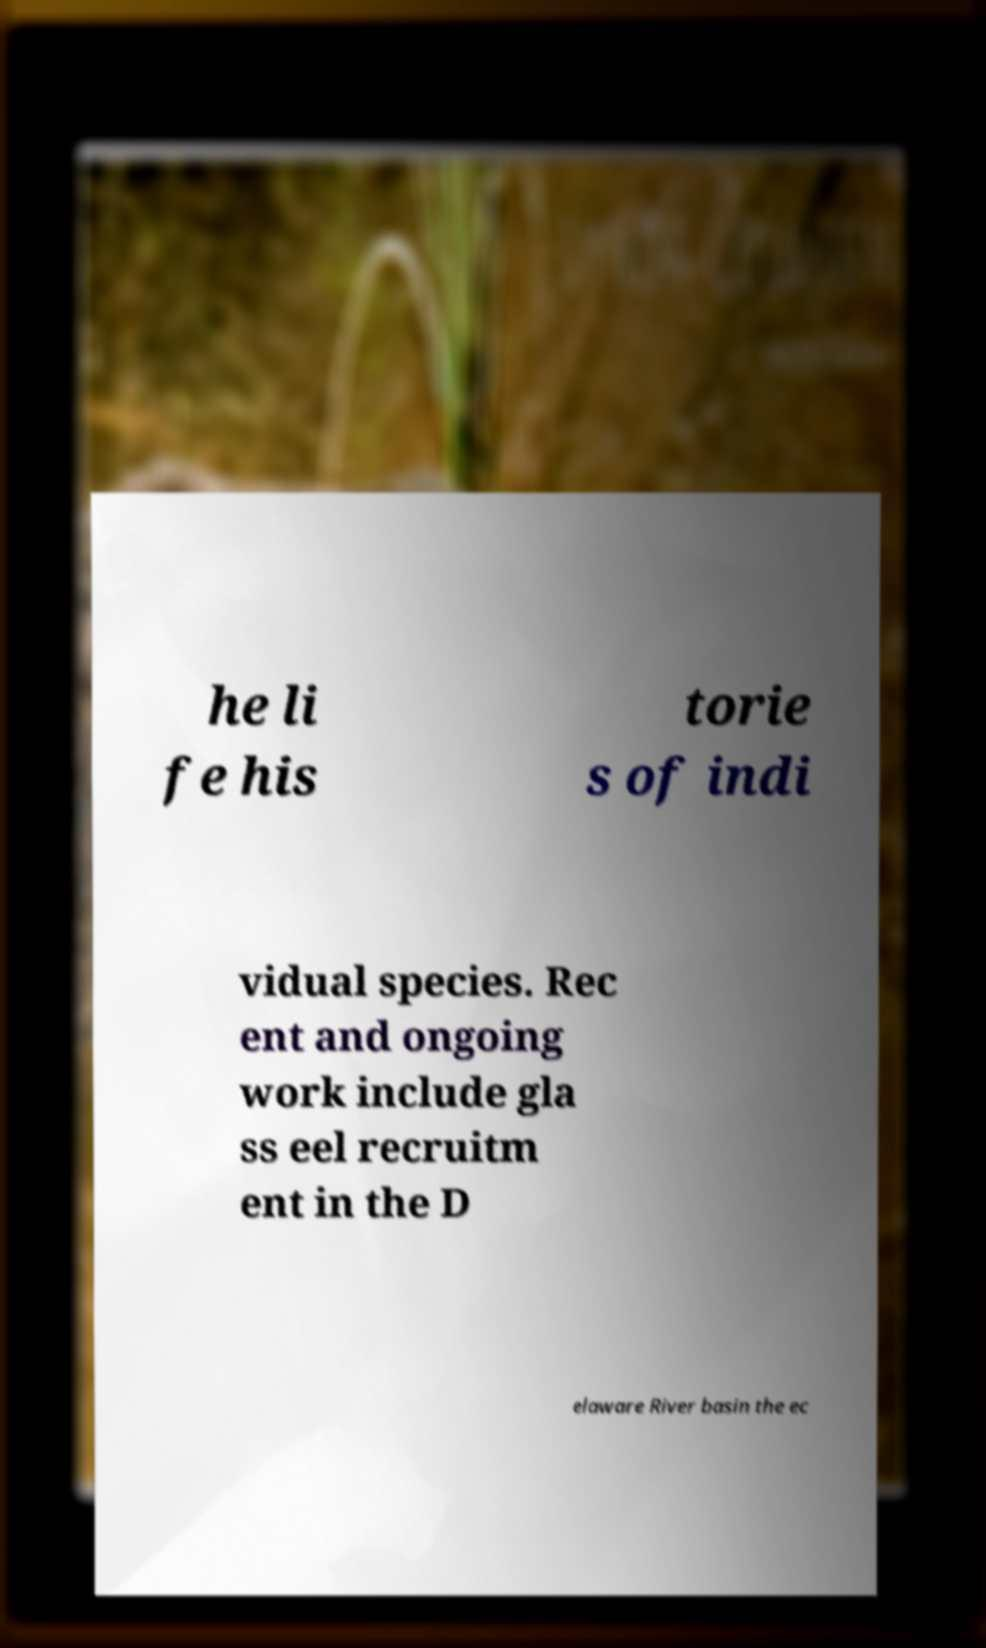There's text embedded in this image that I need extracted. Can you transcribe it verbatim? he li fe his torie s of indi vidual species. Rec ent and ongoing work include gla ss eel recruitm ent in the D elaware River basin the ec 